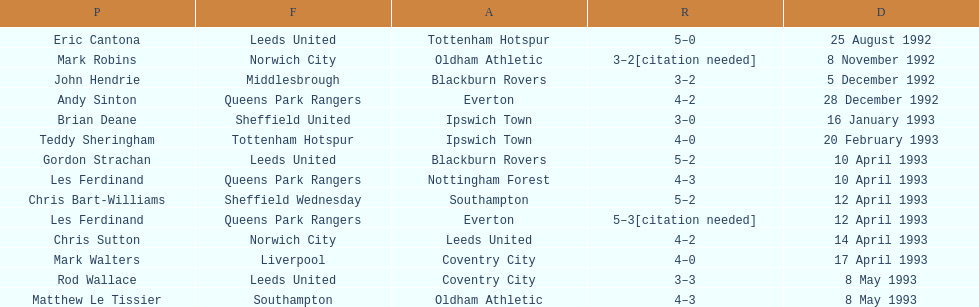How many players were for leeds united? 3. 